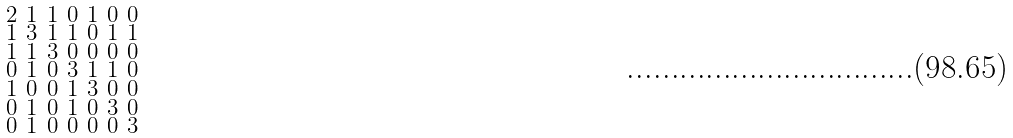<formula> <loc_0><loc_0><loc_500><loc_500>\begin{smallmatrix} 2 & 1 & 1 & 0 & 1 & 0 & 0 \\ 1 & 3 & 1 & 1 & 0 & 1 & 1 \\ 1 & 1 & 3 & 0 & 0 & 0 & 0 \\ 0 & 1 & 0 & 3 & 1 & 1 & 0 \\ 1 & 0 & 0 & 1 & 3 & 0 & 0 \\ 0 & 1 & 0 & 1 & 0 & 3 & 0 \\ 0 & 1 & 0 & 0 & 0 & 0 & 3 \end{smallmatrix}</formula> 